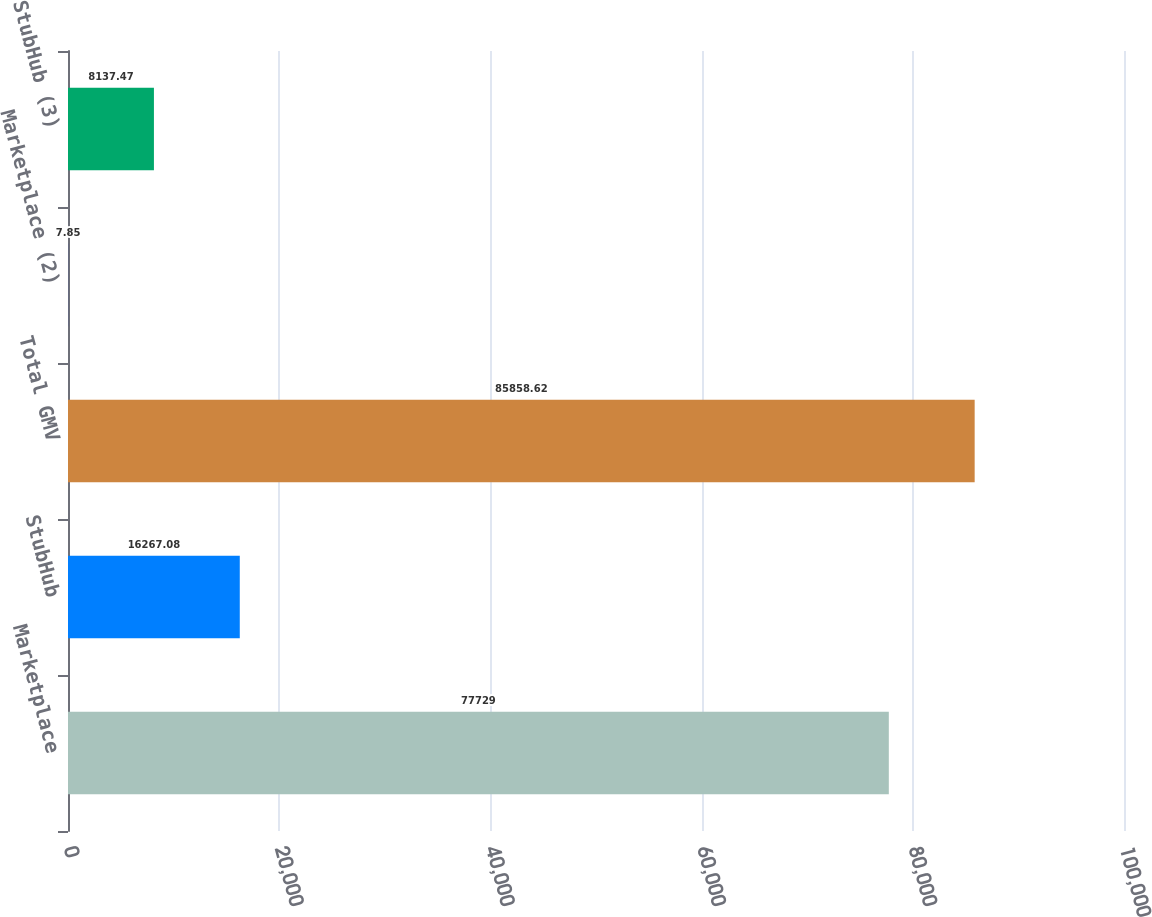Convert chart to OTSL. <chart><loc_0><loc_0><loc_500><loc_500><bar_chart><fcel>Marketplace<fcel>StubHub<fcel>Total GMV<fcel>Marketplace (2)<fcel>StubHub (3)<nl><fcel>77729<fcel>16267.1<fcel>85858.6<fcel>7.85<fcel>8137.47<nl></chart> 